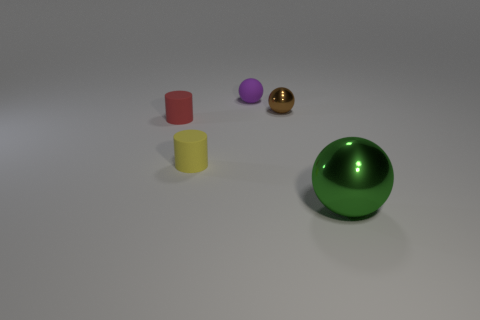Subtract all metallic balls. How many balls are left? 1 Add 1 green objects. How many objects exist? 6 Subtract all yellow cylinders. How many cylinders are left? 1 Add 3 green metal spheres. How many green metal spheres exist? 4 Subtract 0 green cylinders. How many objects are left? 5 Subtract all cylinders. How many objects are left? 3 Subtract 3 spheres. How many spheres are left? 0 Subtract all blue spheres. Subtract all brown cylinders. How many spheres are left? 3 Subtract all cyan blocks. How many gray balls are left? 0 Subtract all tiny rubber objects. Subtract all small yellow rubber spheres. How many objects are left? 2 